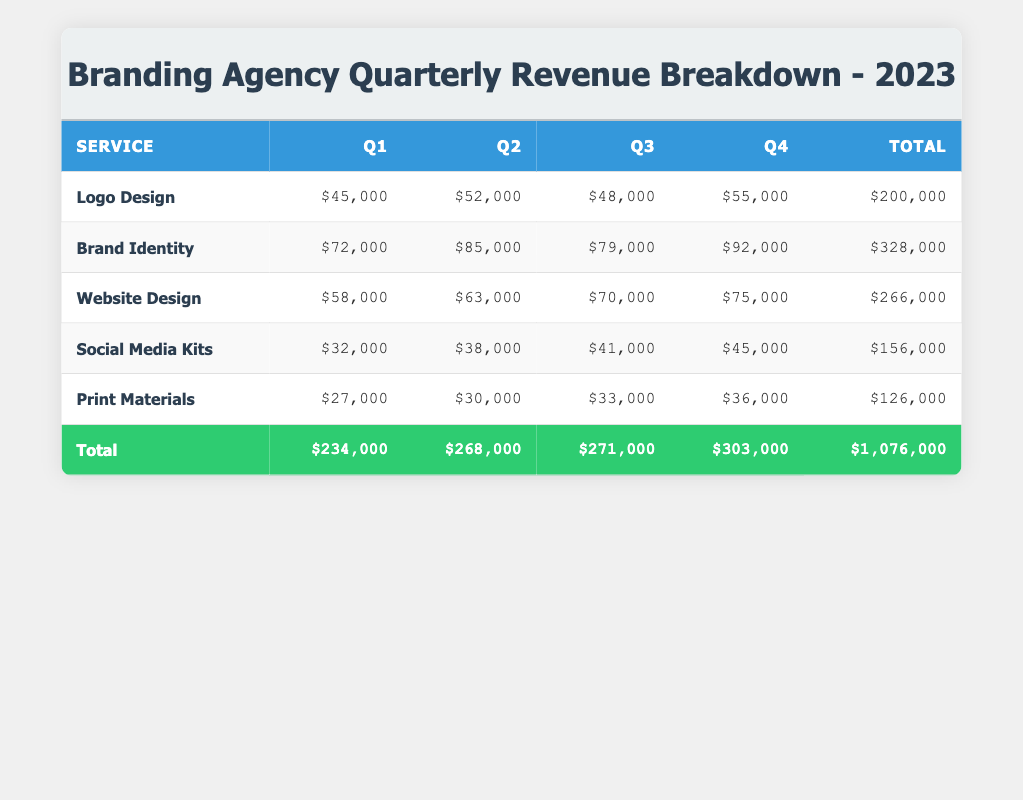What was the revenue for Brand Identity in Q3? According to the table, the revenue for Brand Identity in Q3 was $79,000. You can find this value in the row corresponding to Brand Identity under the Q3 column.
Answer: $79,000 Which service generated the highest revenue in Q2? In Q2, the table shows that Brand Identity had the highest revenue at $85,000. This is determined by comparing the revenues of all services in the Q2 column.
Answer: Brand Identity What is the total revenue for Logo Design across all quarters? To find the total revenue for Logo Design, you add the revenues for all quarters: $45,000 + $52,000 + $48,000 + $55,000 = $200,000. This calculation combines the values from all quarters in the Logo Design row.
Answer: $200,000 Did Social Media Kits have a revenue increase from Q1 to Q4? Yes, Social Media Kits had a revenue increase from Q1 ($32,000) to Q4 ($45,000). You can see this by looking at the values in the Social Media Kits row for both quarters.
Answer: Yes What was the average revenue for Print Materials across the four quarters? To find the average revenue for Print Materials, sum the quarterly revenues: $27,000 + $30,000 + $33,000 + $36,000 = $126,000, and divide by 4 (the number of quarters): $126,000 / 4 = $31,500. This gives you the average calculated from each quarter's revenue value.
Answer: $31,500 Which service had the least total revenue in 2023? Print Materials had the least total revenue in 2023, totaling $126,000, which is the lowest total when comparing the sums of each service in the Total column.
Answer: Print Materials What is the revenue difference between Q1 and Q4 for Website Design? The revenue for Website Design in Q1 is $58,000 and in Q4 is $75,000. The difference is $75,000 - $58,000 = $17,000. This shows how much the revenue increased from Q1 to Q4 for this service.
Answer: $17,000 Is the total revenue for all services in Q3 greater than in Q1? Yes, the total revenue for all services in Q3 is $271,000, while in Q1 it is $234,000. By comparing the two total figures in the Total row for these quarters, you can confirm the increase.
Answer: Yes 